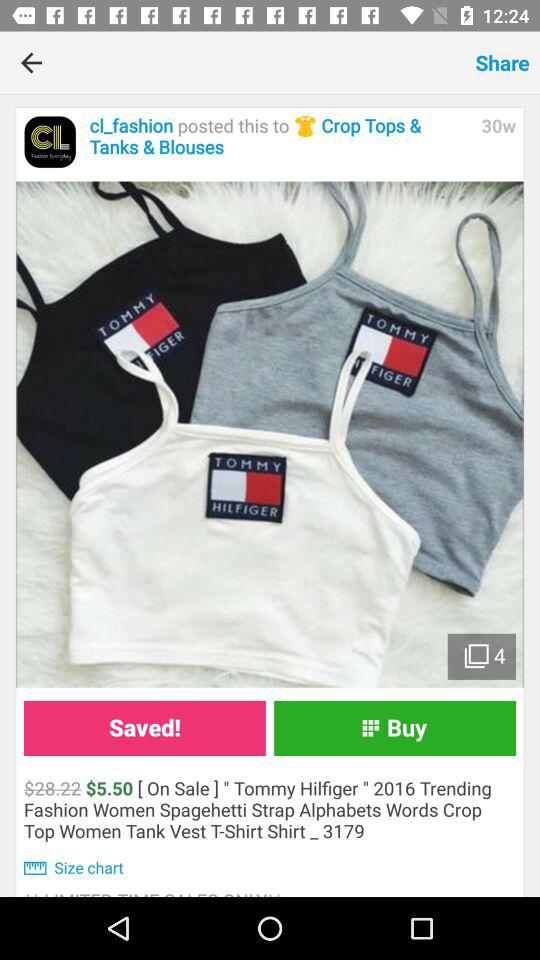Who posted the product to "Crop Tops & Tanks & Blouses"? The product was posted by "cl_fashion". 